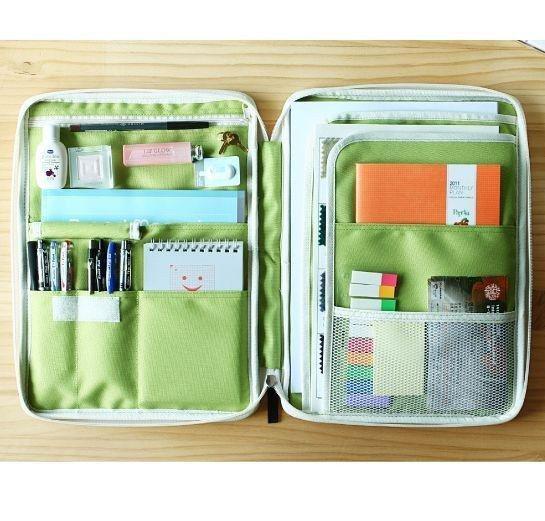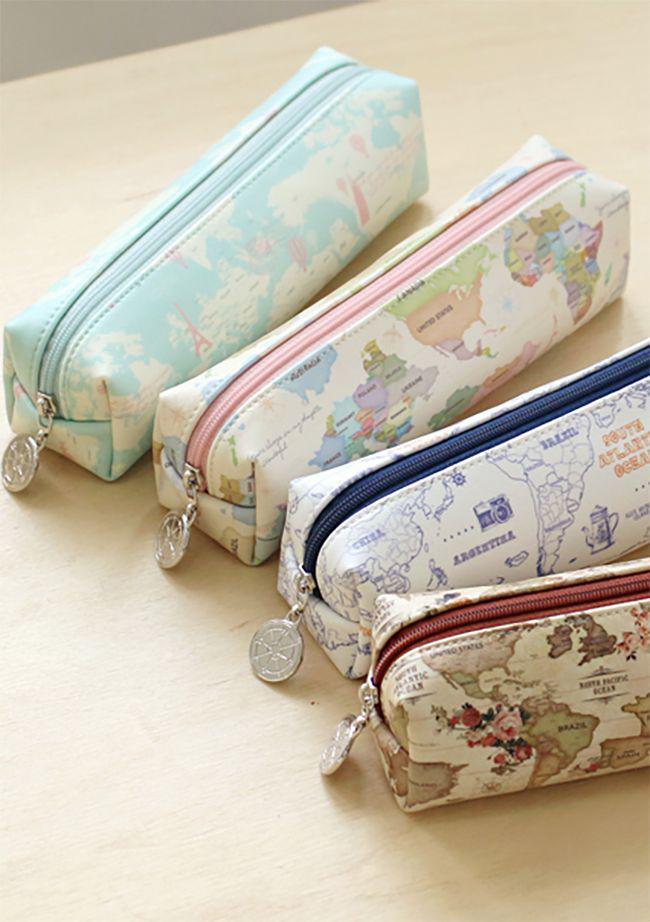The first image is the image on the left, the second image is the image on the right. Analyze the images presented: Is the assertion "The left image shows one case with at least some contents visible." valid? Answer yes or no. Yes. 